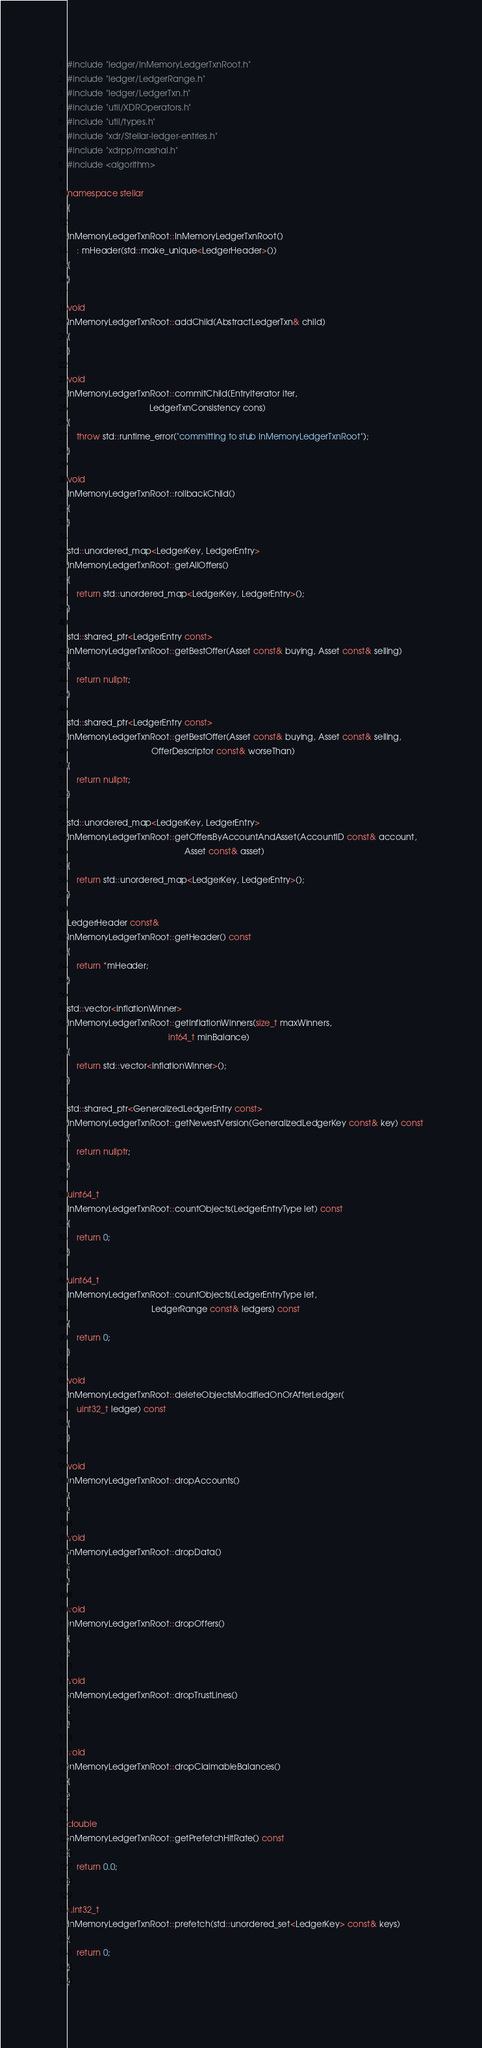Convert code to text. <code><loc_0><loc_0><loc_500><loc_500><_C++_>#include "ledger/InMemoryLedgerTxnRoot.h"
#include "ledger/LedgerRange.h"
#include "ledger/LedgerTxn.h"
#include "util/XDROperators.h"
#include "util/types.h"
#include "xdr/Stellar-ledger-entries.h"
#include "xdrpp/marshal.h"
#include <algorithm>

namespace stellar
{

InMemoryLedgerTxnRoot::InMemoryLedgerTxnRoot()
    : mHeader(std::make_unique<LedgerHeader>())
{
}

void
InMemoryLedgerTxnRoot::addChild(AbstractLedgerTxn& child)
{
}

void
InMemoryLedgerTxnRoot::commitChild(EntryIterator iter,
                                   LedgerTxnConsistency cons)
{
    throw std::runtime_error("committing to stub InMemoryLedgerTxnRoot");
}

void
InMemoryLedgerTxnRoot::rollbackChild()
{
}

std::unordered_map<LedgerKey, LedgerEntry>
InMemoryLedgerTxnRoot::getAllOffers()
{
    return std::unordered_map<LedgerKey, LedgerEntry>();
}

std::shared_ptr<LedgerEntry const>
InMemoryLedgerTxnRoot::getBestOffer(Asset const& buying, Asset const& selling)
{
    return nullptr;
}

std::shared_ptr<LedgerEntry const>
InMemoryLedgerTxnRoot::getBestOffer(Asset const& buying, Asset const& selling,
                                    OfferDescriptor const& worseThan)
{
    return nullptr;
}

std::unordered_map<LedgerKey, LedgerEntry>
InMemoryLedgerTxnRoot::getOffersByAccountAndAsset(AccountID const& account,
                                                  Asset const& asset)
{
    return std::unordered_map<LedgerKey, LedgerEntry>();
}

LedgerHeader const&
InMemoryLedgerTxnRoot::getHeader() const
{
    return *mHeader;
}

std::vector<InflationWinner>
InMemoryLedgerTxnRoot::getInflationWinners(size_t maxWinners,
                                           int64_t minBalance)
{
    return std::vector<InflationWinner>();
}

std::shared_ptr<GeneralizedLedgerEntry const>
InMemoryLedgerTxnRoot::getNewestVersion(GeneralizedLedgerKey const& key) const
{
    return nullptr;
}

uint64_t
InMemoryLedgerTxnRoot::countObjects(LedgerEntryType let) const
{
    return 0;
}

uint64_t
InMemoryLedgerTxnRoot::countObjects(LedgerEntryType let,
                                    LedgerRange const& ledgers) const
{
    return 0;
}

void
InMemoryLedgerTxnRoot::deleteObjectsModifiedOnOrAfterLedger(
    uint32_t ledger) const
{
}

void
InMemoryLedgerTxnRoot::dropAccounts()
{
}

void
InMemoryLedgerTxnRoot::dropData()
{
}

void
InMemoryLedgerTxnRoot::dropOffers()
{
}

void
InMemoryLedgerTxnRoot::dropTrustLines()
{
}

void
InMemoryLedgerTxnRoot::dropClaimableBalances()
{
}

double
InMemoryLedgerTxnRoot::getPrefetchHitRate() const
{
    return 0.0;
}

uint32_t
InMemoryLedgerTxnRoot::prefetch(std::unordered_set<LedgerKey> const& keys)
{
    return 0;
}
}
</code> 